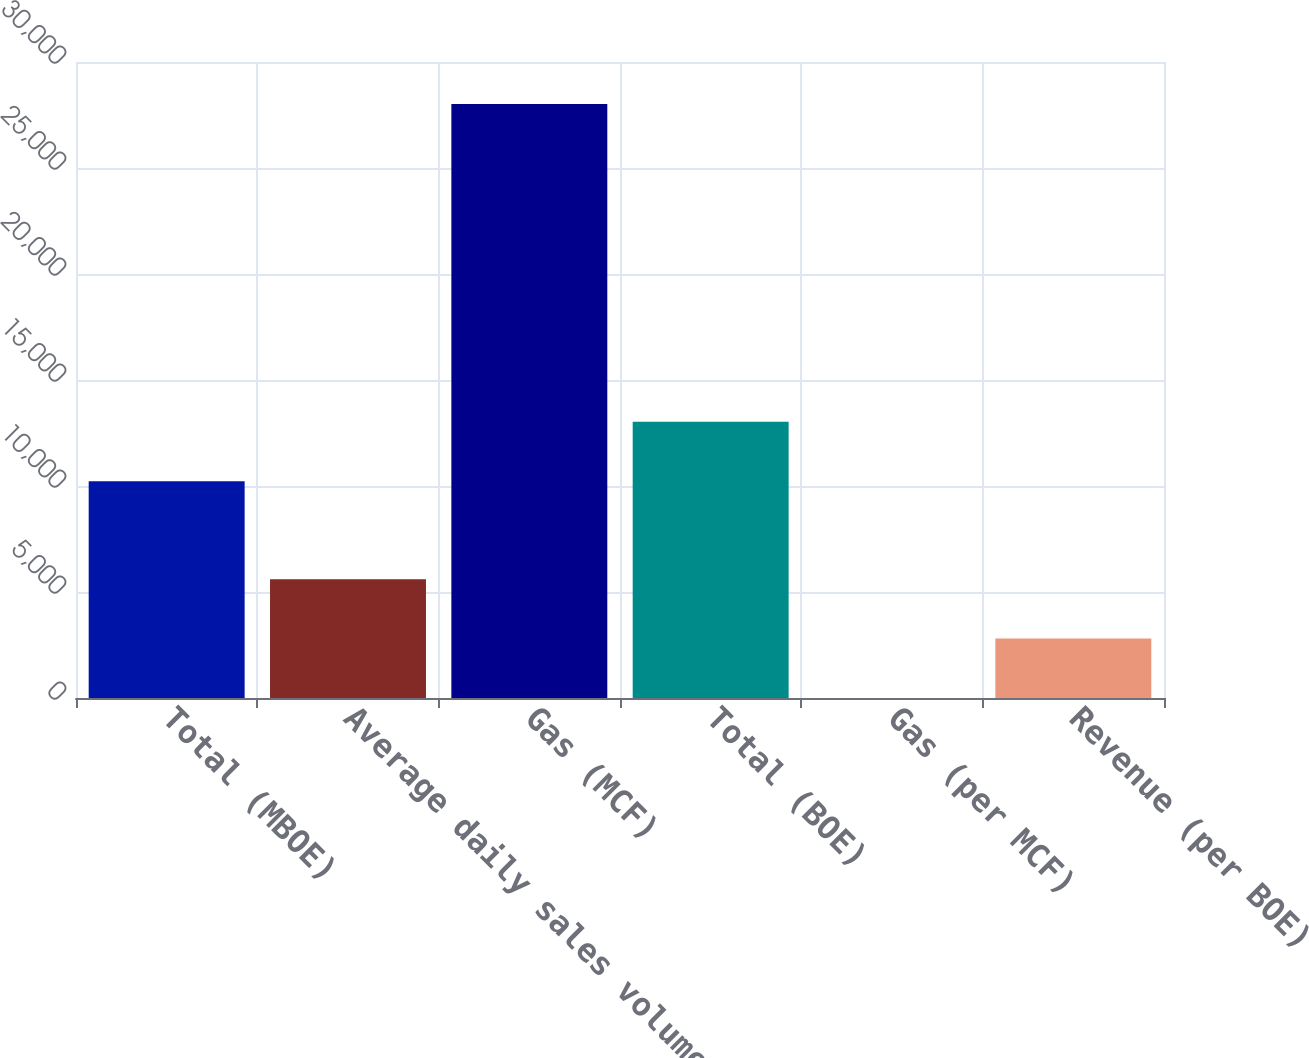<chart> <loc_0><loc_0><loc_500><loc_500><bar_chart><fcel>Total (MBOE)<fcel>Average daily sales volumes<fcel>Gas (MCF)<fcel>Total (BOE)<fcel>Gas (per MCF)<fcel>Revenue (per BOE)<nl><fcel>10227<fcel>5607.15<fcel>28020<fcel>13028.6<fcel>3.93<fcel>2805.54<nl></chart> 